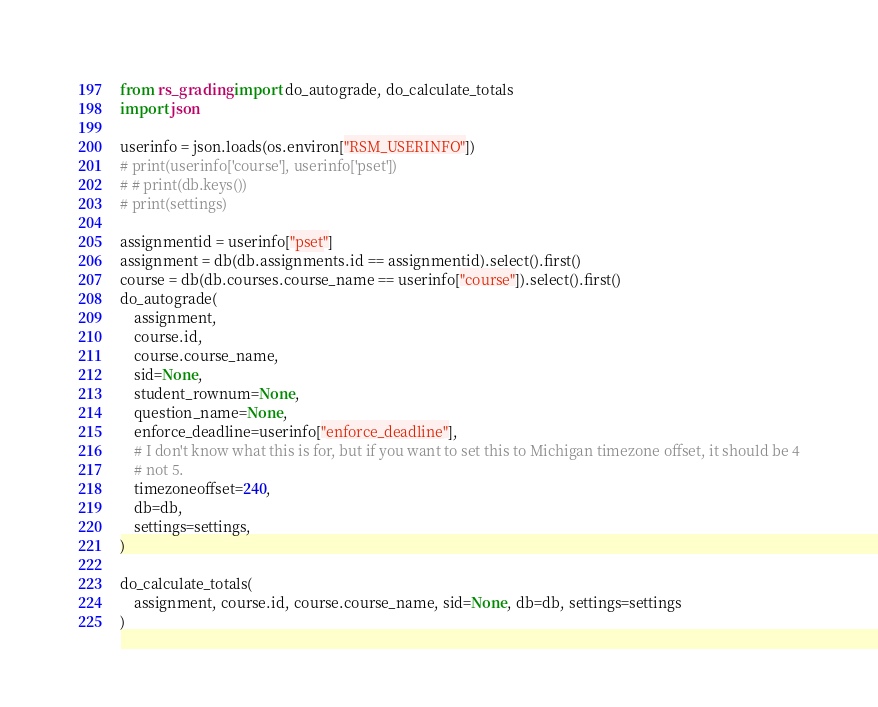Convert code to text. <code><loc_0><loc_0><loc_500><loc_500><_Python_>from rs_grading import do_autograde, do_calculate_totals
import json

userinfo = json.loads(os.environ["RSM_USERINFO"])
# print(userinfo['course'], userinfo['pset'])
# # print(db.keys())
# print(settings)

assignmentid = userinfo["pset"]
assignment = db(db.assignments.id == assignmentid).select().first()
course = db(db.courses.course_name == userinfo["course"]).select().first()
do_autograde(
    assignment,
    course.id,
    course.course_name,
    sid=None,
    student_rownum=None,
    question_name=None,
    enforce_deadline=userinfo["enforce_deadline"],
    # I don't know what this is for, but if you want to set this to Michigan timezone offset, it should be 4
    # not 5.
    timezoneoffset=240,
    db=db,
    settings=settings,
)

do_calculate_totals(
    assignment, course.id, course.course_name, sid=None, db=db, settings=settings
)
</code> 